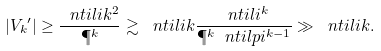<formula> <loc_0><loc_0><loc_500><loc_500>| { V _ { k } } ^ { \prime } | \geq \frac { \ n t i l i k ^ { 2 } } { \P ^ { k } } \gtrsim \ n t i l i k \frac { \ n t i l i ^ { k } } { \P ^ { k } \ n t i l p i ^ { k - 1 } } \gg \ n t i l i k .</formula> 